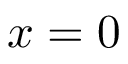Convert formula to latex. <formula><loc_0><loc_0><loc_500><loc_500>x = 0</formula> 